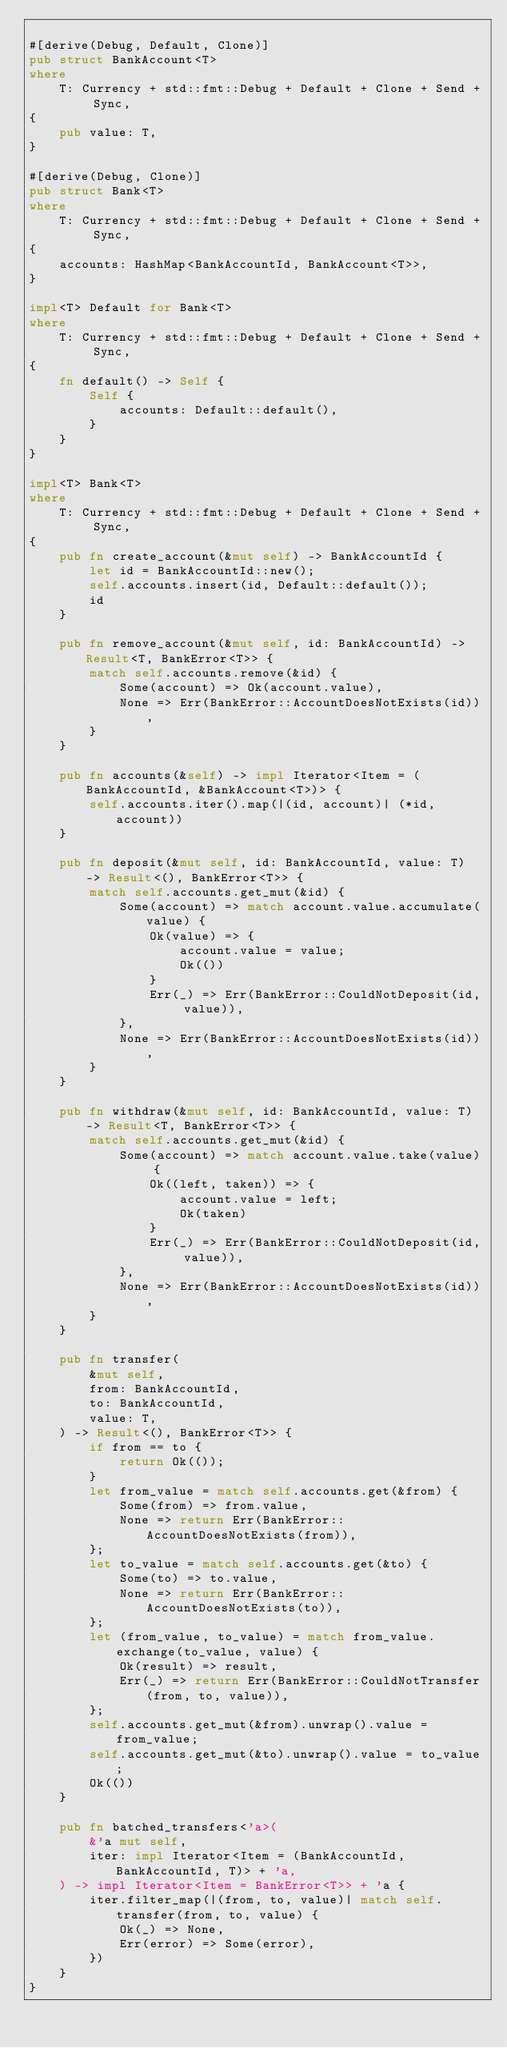Convert code to text. <code><loc_0><loc_0><loc_500><loc_500><_Rust_>
#[derive(Debug, Default, Clone)]
pub struct BankAccount<T>
where
    T: Currency + std::fmt::Debug + Default + Clone + Send + Sync,
{
    pub value: T,
}

#[derive(Debug, Clone)]
pub struct Bank<T>
where
    T: Currency + std::fmt::Debug + Default + Clone + Send + Sync,
{
    accounts: HashMap<BankAccountId, BankAccount<T>>,
}

impl<T> Default for Bank<T>
where
    T: Currency + std::fmt::Debug + Default + Clone + Send + Sync,
{
    fn default() -> Self {
        Self {
            accounts: Default::default(),
        }
    }
}

impl<T> Bank<T>
where
    T: Currency + std::fmt::Debug + Default + Clone + Send + Sync,
{
    pub fn create_account(&mut self) -> BankAccountId {
        let id = BankAccountId::new();
        self.accounts.insert(id, Default::default());
        id
    }

    pub fn remove_account(&mut self, id: BankAccountId) -> Result<T, BankError<T>> {
        match self.accounts.remove(&id) {
            Some(account) => Ok(account.value),
            None => Err(BankError::AccountDoesNotExists(id)),
        }
    }

    pub fn accounts(&self) -> impl Iterator<Item = (BankAccountId, &BankAccount<T>)> {
        self.accounts.iter().map(|(id, account)| (*id, account))
    }

    pub fn deposit(&mut self, id: BankAccountId, value: T) -> Result<(), BankError<T>> {
        match self.accounts.get_mut(&id) {
            Some(account) => match account.value.accumulate(value) {
                Ok(value) => {
                    account.value = value;
                    Ok(())
                }
                Err(_) => Err(BankError::CouldNotDeposit(id, value)),
            },
            None => Err(BankError::AccountDoesNotExists(id)),
        }
    }

    pub fn withdraw(&mut self, id: BankAccountId, value: T) -> Result<T, BankError<T>> {
        match self.accounts.get_mut(&id) {
            Some(account) => match account.value.take(value) {
                Ok((left, taken)) => {
                    account.value = left;
                    Ok(taken)
                }
                Err(_) => Err(BankError::CouldNotDeposit(id, value)),
            },
            None => Err(BankError::AccountDoesNotExists(id)),
        }
    }

    pub fn transfer(
        &mut self,
        from: BankAccountId,
        to: BankAccountId,
        value: T,
    ) -> Result<(), BankError<T>> {
        if from == to {
            return Ok(());
        }
        let from_value = match self.accounts.get(&from) {
            Some(from) => from.value,
            None => return Err(BankError::AccountDoesNotExists(from)),
        };
        let to_value = match self.accounts.get(&to) {
            Some(to) => to.value,
            None => return Err(BankError::AccountDoesNotExists(to)),
        };
        let (from_value, to_value) = match from_value.exchange(to_value, value) {
            Ok(result) => result,
            Err(_) => return Err(BankError::CouldNotTransfer(from, to, value)),
        };
        self.accounts.get_mut(&from).unwrap().value = from_value;
        self.accounts.get_mut(&to).unwrap().value = to_value;
        Ok(())
    }

    pub fn batched_transfers<'a>(
        &'a mut self,
        iter: impl Iterator<Item = (BankAccountId, BankAccountId, T)> + 'a,
    ) -> impl Iterator<Item = BankError<T>> + 'a {
        iter.filter_map(|(from, to, value)| match self.transfer(from, to, value) {
            Ok(_) => None,
            Err(error) => Some(error),
        })
    }
}
</code> 